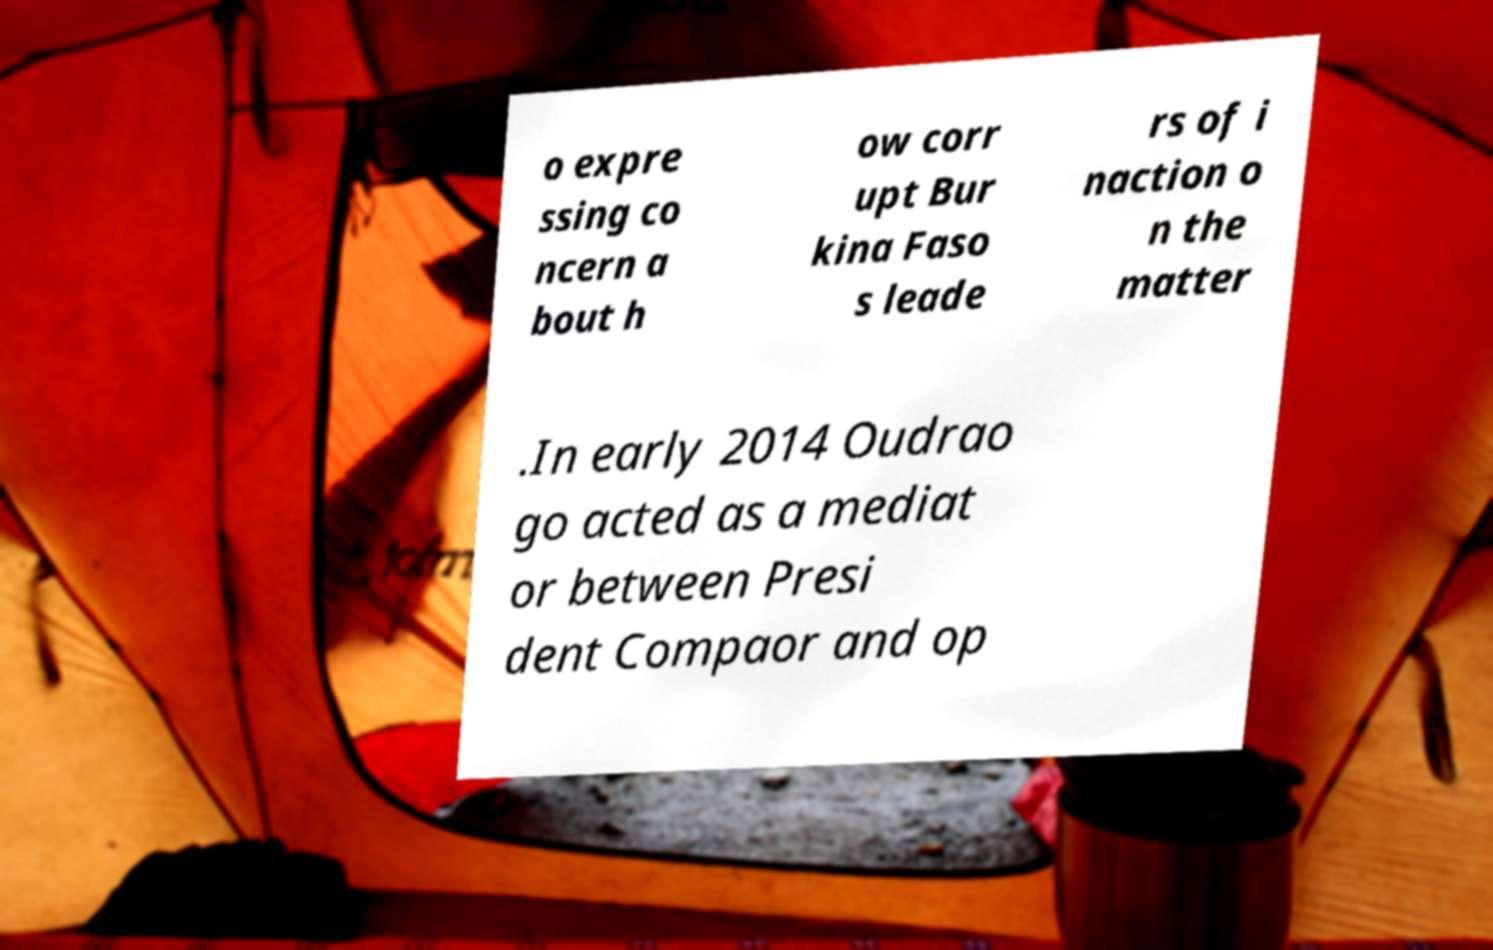There's text embedded in this image that I need extracted. Can you transcribe it verbatim? o expre ssing co ncern a bout h ow corr upt Bur kina Faso s leade rs of i naction o n the matter .In early 2014 Oudrao go acted as a mediat or between Presi dent Compaor and op 